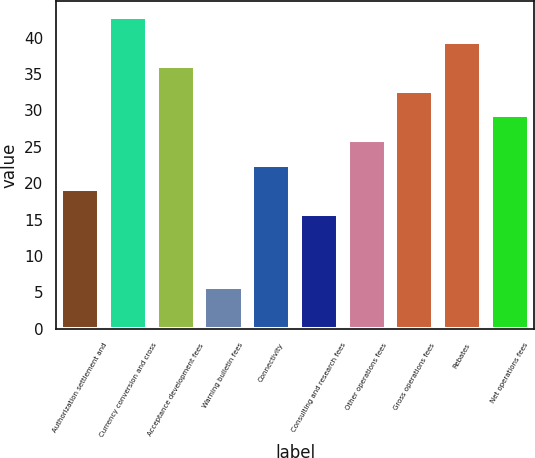<chart> <loc_0><loc_0><loc_500><loc_500><bar_chart><fcel>Authorization settlement and<fcel>Currency conversion and cross<fcel>Acceptance development fees<fcel>Warning bulletin fees<fcel>Connectivity<fcel>Consulting and research fees<fcel>Other operations fees<fcel>Gross operations fees<fcel>Rebates<fcel>Net operations fees<nl><fcel>19.18<fcel>42.84<fcel>36.08<fcel>5.7<fcel>22.56<fcel>15.8<fcel>25.94<fcel>32.7<fcel>39.46<fcel>29.32<nl></chart> 